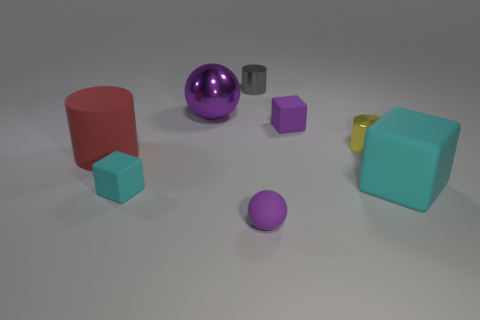Add 2 cyan things. How many objects exist? 10 Subtract all cylinders. How many objects are left? 5 Add 5 big things. How many big things are left? 8 Add 8 small brown blocks. How many small brown blocks exist? 8 Subtract 0 purple cylinders. How many objects are left? 8 Subtract all small gray metallic cylinders. Subtract all small blue metal balls. How many objects are left? 7 